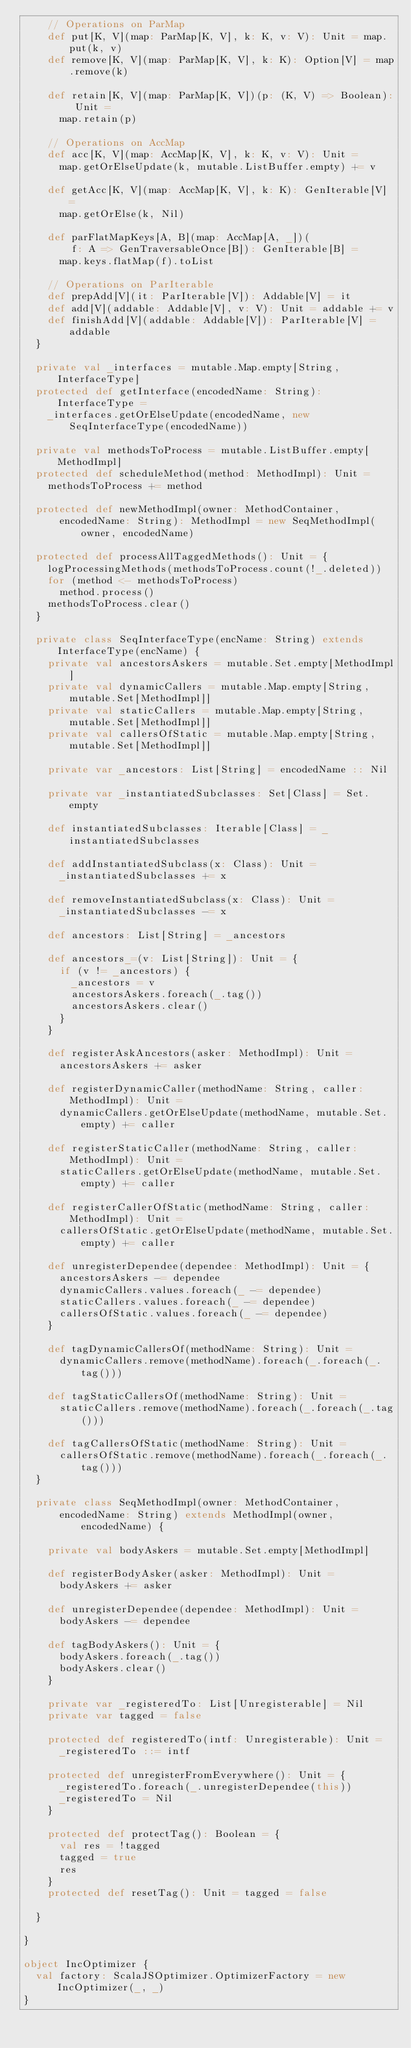Convert code to text. <code><loc_0><loc_0><loc_500><loc_500><_Scala_>    // Operations on ParMap
    def put[K, V](map: ParMap[K, V], k: K, v: V): Unit = map.put(k, v)
    def remove[K, V](map: ParMap[K, V], k: K): Option[V] = map.remove(k)

    def retain[K, V](map: ParMap[K, V])(p: (K, V) => Boolean): Unit =
      map.retain(p)

    // Operations on AccMap
    def acc[K, V](map: AccMap[K, V], k: K, v: V): Unit =
      map.getOrElseUpdate(k, mutable.ListBuffer.empty) += v

    def getAcc[K, V](map: AccMap[K, V], k: K): GenIterable[V] =
      map.getOrElse(k, Nil)

    def parFlatMapKeys[A, B](map: AccMap[A, _])(
        f: A => GenTraversableOnce[B]): GenIterable[B] =
      map.keys.flatMap(f).toList

    // Operations on ParIterable
    def prepAdd[V](it: ParIterable[V]): Addable[V] = it
    def add[V](addable: Addable[V], v: V): Unit = addable += v
    def finishAdd[V](addable: Addable[V]): ParIterable[V] = addable
  }

  private val _interfaces = mutable.Map.empty[String, InterfaceType]
  protected def getInterface(encodedName: String): InterfaceType =
    _interfaces.getOrElseUpdate(encodedName, new SeqInterfaceType(encodedName))

  private val methodsToProcess = mutable.ListBuffer.empty[MethodImpl]
  protected def scheduleMethod(method: MethodImpl): Unit =
    methodsToProcess += method

  protected def newMethodImpl(owner: MethodContainer,
      encodedName: String): MethodImpl = new SeqMethodImpl(owner, encodedName)

  protected def processAllTaggedMethods(): Unit = {
    logProcessingMethods(methodsToProcess.count(!_.deleted))
    for (method <- methodsToProcess)
      method.process()
    methodsToProcess.clear()
  }

  private class SeqInterfaceType(encName: String) extends InterfaceType(encName) {
    private val ancestorsAskers = mutable.Set.empty[MethodImpl]
    private val dynamicCallers = mutable.Map.empty[String, mutable.Set[MethodImpl]]
    private val staticCallers = mutable.Map.empty[String, mutable.Set[MethodImpl]]
    private val callersOfStatic = mutable.Map.empty[String, mutable.Set[MethodImpl]]

    private var _ancestors: List[String] = encodedName :: Nil

    private var _instantiatedSubclasses: Set[Class] = Set.empty

    def instantiatedSubclasses: Iterable[Class] = _instantiatedSubclasses

    def addInstantiatedSubclass(x: Class): Unit =
      _instantiatedSubclasses += x

    def removeInstantiatedSubclass(x: Class): Unit =
      _instantiatedSubclasses -= x

    def ancestors: List[String] = _ancestors

    def ancestors_=(v: List[String]): Unit = {
      if (v != _ancestors) {
        _ancestors = v
        ancestorsAskers.foreach(_.tag())
        ancestorsAskers.clear()
      }
    }

    def registerAskAncestors(asker: MethodImpl): Unit =
      ancestorsAskers += asker

    def registerDynamicCaller(methodName: String, caller: MethodImpl): Unit =
      dynamicCallers.getOrElseUpdate(methodName, mutable.Set.empty) += caller

    def registerStaticCaller(methodName: String, caller: MethodImpl): Unit =
      staticCallers.getOrElseUpdate(methodName, mutable.Set.empty) += caller

    def registerCallerOfStatic(methodName: String, caller: MethodImpl): Unit =
      callersOfStatic.getOrElseUpdate(methodName, mutable.Set.empty) += caller

    def unregisterDependee(dependee: MethodImpl): Unit = {
      ancestorsAskers -= dependee
      dynamicCallers.values.foreach(_ -= dependee)
      staticCallers.values.foreach(_ -= dependee)
      callersOfStatic.values.foreach(_ -= dependee)
    }

    def tagDynamicCallersOf(methodName: String): Unit =
      dynamicCallers.remove(methodName).foreach(_.foreach(_.tag()))

    def tagStaticCallersOf(methodName: String): Unit =
      staticCallers.remove(methodName).foreach(_.foreach(_.tag()))

    def tagCallersOfStatic(methodName: String): Unit =
      callersOfStatic.remove(methodName).foreach(_.foreach(_.tag()))
  }

  private class SeqMethodImpl(owner: MethodContainer,
      encodedName: String) extends MethodImpl(owner, encodedName) {

    private val bodyAskers = mutable.Set.empty[MethodImpl]

    def registerBodyAsker(asker: MethodImpl): Unit =
      bodyAskers += asker

    def unregisterDependee(dependee: MethodImpl): Unit =
      bodyAskers -= dependee

    def tagBodyAskers(): Unit = {
      bodyAskers.foreach(_.tag())
      bodyAskers.clear()
    }

    private var _registeredTo: List[Unregisterable] = Nil
    private var tagged = false

    protected def registeredTo(intf: Unregisterable): Unit =
      _registeredTo ::= intf

    protected def unregisterFromEverywhere(): Unit = {
      _registeredTo.foreach(_.unregisterDependee(this))
      _registeredTo = Nil
    }

    protected def protectTag(): Boolean = {
      val res = !tagged
      tagged = true
      res
    }
    protected def resetTag(): Unit = tagged = false

  }

}

object IncOptimizer {
  val factory: ScalaJSOptimizer.OptimizerFactory = new IncOptimizer(_, _)
}
</code> 